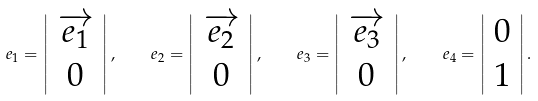<formula> <loc_0><loc_0><loc_500><loc_500>e _ { 1 } = \left | \begin{array} { c } { { \overrightarrow { e _ { 1 } } } } \\ { 0 } \end{array} \right | , \quad e _ { 2 } = \left | \begin{array} { c } { { \overrightarrow { e _ { 2 } } } } \\ { 0 } \end{array} \right | , \quad e _ { 3 } = \left | \begin{array} { c } { { \overrightarrow { e _ { 3 } } } } \\ { 0 } \end{array} \right | , \quad e _ { 4 } = \left | \begin{array} { c } { 0 } \\ { 1 } \end{array} \right | .</formula> 